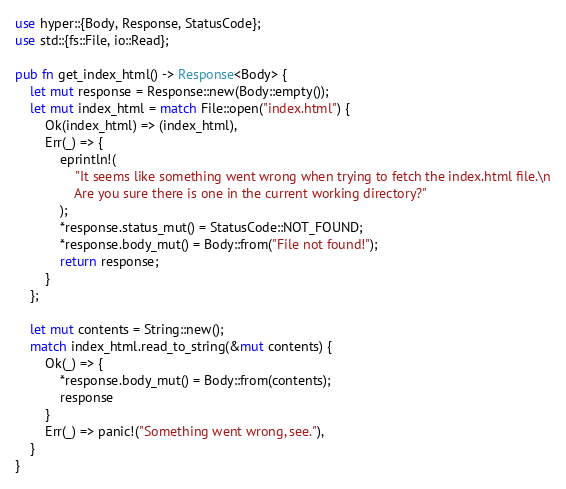Convert code to text. <code><loc_0><loc_0><loc_500><loc_500><_Rust_>use hyper::{Body, Response, StatusCode};
use std::{fs::File, io::Read};

pub fn get_index_html() -> Response<Body> {
    let mut response = Response::new(Body::empty());
    let mut index_html = match File::open("index.html") {
        Ok(index_html) => (index_html),
        Err(_) => {
            eprintln!(
                "It seems like something went wrong when trying to fetch the index.html file.\n
                Are you sure there is one in the current working directory?"
            );
            *response.status_mut() = StatusCode::NOT_FOUND;
            *response.body_mut() = Body::from("File not found!");
            return response;
        }
    };

    let mut contents = String::new();
    match index_html.read_to_string(&mut contents) {
        Ok(_) => {
            *response.body_mut() = Body::from(contents);
            response
        }
        Err(_) => panic!("Something went wrong, see."),
    }
}
</code> 